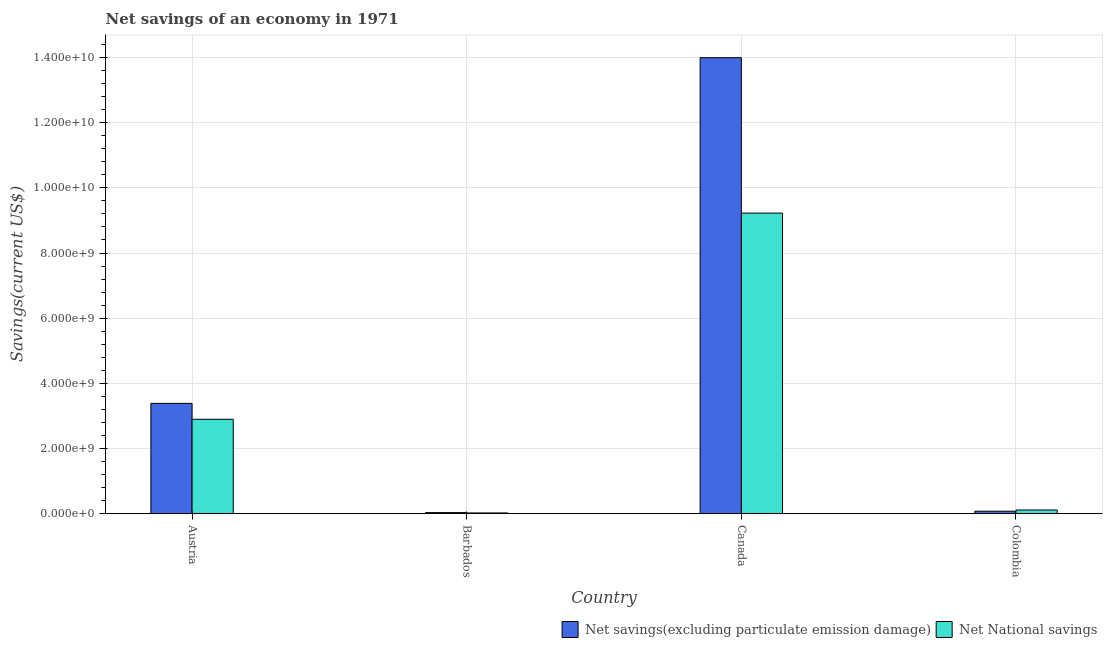How many different coloured bars are there?
Ensure brevity in your answer.  2. Are the number of bars per tick equal to the number of legend labels?
Offer a terse response. Yes. Are the number of bars on each tick of the X-axis equal?
Your response must be concise. Yes. How many bars are there on the 3rd tick from the right?
Offer a terse response. 2. What is the net national savings in Austria?
Provide a succinct answer. 2.90e+09. Across all countries, what is the maximum net national savings?
Provide a short and direct response. 9.23e+09. Across all countries, what is the minimum net savings(excluding particulate emission damage)?
Your answer should be very brief. 3.18e+07. In which country was the net national savings minimum?
Offer a terse response. Barbados. What is the total net national savings in the graph?
Your answer should be compact. 1.23e+1. What is the difference between the net national savings in Austria and that in Canada?
Provide a succinct answer. -6.33e+09. What is the difference between the net national savings in Canada and the net savings(excluding particulate emission damage) in Colombia?
Ensure brevity in your answer.  9.15e+09. What is the average net savings(excluding particulate emission damage) per country?
Ensure brevity in your answer.  4.37e+09. What is the difference between the net savings(excluding particulate emission damage) and net national savings in Austria?
Provide a succinct answer. 4.89e+08. In how many countries, is the net national savings greater than 2800000000 US$?
Your answer should be very brief. 2. What is the ratio of the net national savings in Austria to that in Canada?
Keep it short and to the point. 0.31. What is the difference between the highest and the second highest net savings(excluding particulate emission damage)?
Your answer should be very brief. 1.06e+1. What is the difference between the highest and the lowest net savings(excluding particulate emission damage)?
Provide a short and direct response. 1.40e+1. What does the 2nd bar from the left in Austria represents?
Give a very brief answer. Net National savings. What does the 2nd bar from the right in Colombia represents?
Ensure brevity in your answer.  Net savings(excluding particulate emission damage). Are all the bars in the graph horizontal?
Offer a terse response. No. How many countries are there in the graph?
Your answer should be very brief. 4. What is the difference between two consecutive major ticks on the Y-axis?
Offer a terse response. 2.00e+09. Does the graph contain any zero values?
Your response must be concise. No. Does the graph contain grids?
Provide a succinct answer. Yes. Where does the legend appear in the graph?
Offer a terse response. Bottom right. How many legend labels are there?
Offer a terse response. 2. What is the title of the graph?
Provide a short and direct response. Net savings of an economy in 1971. What is the label or title of the Y-axis?
Your response must be concise. Savings(current US$). What is the Savings(current US$) in Net savings(excluding particulate emission damage) in Austria?
Your response must be concise. 3.38e+09. What is the Savings(current US$) of Net National savings in Austria?
Ensure brevity in your answer.  2.90e+09. What is the Savings(current US$) of Net savings(excluding particulate emission damage) in Barbados?
Provide a short and direct response. 3.18e+07. What is the Savings(current US$) in Net National savings in Barbados?
Keep it short and to the point. 2.17e+07. What is the Savings(current US$) in Net savings(excluding particulate emission damage) in Canada?
Your response must be concise. 1.40e+1. What is the Savings(current US$) of Net National savings in Canada?
Provide a short and direct response. 9.23e+09. What is the Savings(current US$) in Net savings(excluding particulate emission damage) in Colombia?
Ensure brevity in your answer.  7.46e+07. What is the Savings(current US$) in Net National savings in Colombia?
Ensure brevity in your answer.  1.11e+08. Across all countries, what is the maximum Savings(current US$) in Net savings(excluding particulate emission damage)?
Give a very brief answer. 1.40e+1. Across all countries, what is the maximum Savings(current US$) of Net National savings?
Provide a succinct answer. 9.23e+09. Across all countries, what is the minimum Savings(current US$) of Net savings(excluding particulate emission damage)?
Give a very brief answer. 3.18e+07. Across all countries, what is the minimum Savings(current US$) in Net National savings?
Your answer should be very brief. 2.17e+07. What is the total Savings(current US$) of Net savings(excluding particulate emission damage) in the graph?
Provide a short and direct response. 1.75e+1. What is the total Savings(current US$) of Net National savings in the graph?
Provide a short and direct response. 1.23e+1. What is the difference between the Savings(current US$) in Net savings(excluding particulate emission damage) in Austria and that in Barbados?
Offer a terse response. 3.35e+09. What is the difference between the Savings(current US$) in Net National savings in Austria and that in Barbados?
Offer a terse response. 2.87e+09. What is the difference between the Savings(current US$) of Net savings(excluding particulate emission damage) in Austria and that in Canada?
Provide a succinct answer. -1.06e+1. What is the difference between the Savings(current US$) in Net National savings in Austria and that in Canada?
Provide a succinct answer. -6.33e+09. What is the difference between the Savings(current US$) in Net savings(excluding particulate emission damage) in Austria and that in Colombia?
Offer a very short reply. 3.31e+09. What is the difference between the Savings(current US$) of Net National savings in Austria and that in Colombia?
Offer a terse response. 2.78e+09. What is the difference between the Savings(current US$) of Net savings(excluding particulate emission damage) in Barbados and that in Canada?
Make the answer very short. -1.40e+1. What is the difference between the Savings(current US$) in Net National savings in Barbados and that in Canada?
Your answer should be compact. -9.20e+09. What is the difference between the Savings(current US$) of Net savings(excluding particulate emission damage) in Barbados and that in Colombia?
Give a very brief answer. -4.28e+07. What is the difference between the Savings(current US$) in Net National savings in Barbados and that in Colombia?
Ensure brevity in your answer.  -8.97e+07. What is the difference between the Savings(current US$) in Net savings(excluding particulate emission damage) in Canada and that in Colombia?
Make the answer very short. 1.39e+1. What is the difference between the Savings(current US$) of Net National savings in Canada and that in Colombia?
Offer a very short reply. 9.11e+09. What is the difference between the Savings(current US$) of Net savings(excluding particulate emission damage) in Austria and the Savings(current US$) of Net National savings in Barbados?
Give a very brief answer. 3.36e+09. What is the difference between the Savings(current US$) in Net savings(excluding particulate emission damage) in Austria and the Savings(current US$) in Net National savings in Canada?
Your response must be concise. -5.84e+09. What is the difference between the Savings(current US$) in Net savings(excluding particulate emission damage) in Austria and the Savings(current US$) in Net National savings in Colombia?
Give a very brief answer. 3.27e+09. What is the difference between the Savings(current US$) of Net savings(excluding particulate emission damage) in Barbados and the Savings(current US$) of Net National savings in Canada?
Provide a succinct answer. -9.19e+09. What is the difference between the Savings(current US$) in Net savings(excluding particulate emission damage) in Barbados and the Savings(current US$) in Net National savings in Colombia?
Your response must be concise. -7.96e+07. What is the difference between the Savings(current US$) of Net savings(excluding particulate emission damage) in Canada and the Savings(current US$) of Net National savings in Colombia?
Keep it short and to the point. 1.39e+1. What is the average Savings(current US$) in Net savings(excluding particulate emission damage) per country?
Your answer should be very brief. 4.37e+09. What is the average Savings(current US$) in Net National savings per country?
Offer a very short reply. 3.06e+09. What is the difference between the Savings(current US$) of Net savings(excluding particulate emission damage) and Savings(current US$) of Net National savings in Austria?
Keep it short and to the point. 4.89e+08. What is the difference between the Savings(current US$) in Net savings(excluding particulate emission damage) and Savings(current US$) in Net National savings in Barbados?
Make the answer very short. 1.01e+07. What is the difference between the Savings(current US$) in Net savings(excluding particulate emission damage) and Savings(current US$) in Net National savings in Canada?
Make the answer very short. 4.77e+09. What is the difference between the Savings(current US$) in Net savings(excluding particulate emission damage) and Savings(current US$) in Net National savings in Colombia?
Give a very brief answer. -3.68e+07. What is the ratio of the Savings(current US$) of Net savings(excluding particulate emission damage) in Austria to that in Barbados?
Provide a short and direct response. 106.5. What is the ratio of the Savings(current US$) in Net National savings in Austria to that in Barbados?
Make the answer very short. 133.41. What is the ratio of the Savings(current US$) of Net savings(excluding particulate emission damage) in Austria to that in Canada?
Keep it short and to the point. 0.24. What is the ratio of the Savings(current US$) of Net National savings in Austria to that in Canada?
Your answer should be compact. 0.31. What is the ratio of the Savings(current US$) of Net savings(excluding particulate emission damage) in Austria to that in Colombia?
Offer a very short reply. 45.37. What is the ratio of the Savings(current US$) of Net National savings in Austria to that in Colombia?
Offer a terse response. 25.99. What is the ratio of the Savings(current US$) of Net savings(excluding particulate emission damage) in Barbados to that in Canada?
Make the answer very short. 0. What is the ratio of the Savings(current US$) of Net National savings in Barbados to that in Canada?
Offer a very short reply. 0. What is the ratio of the Savings(current US$) of Net savings(excluding particulate emission damage) in Barbados to that in Colombia?
Your response must be concise. 0.43. What is the ratio of the Savings(current US$) in Net National savings in Barbados to that in Colombia?
Make the answer very short. 0.19. What is the ratio of the Savings(current US$) of Net savings(excluding particulate emission damage) in Canada to that in Colombia?
Offer a very short reply. 187.59. What is the ratio of the Savings(current US$) of Net National savings in Canada to that in Colombia?
Offer a terse response. 82.79. What is the difference between the highest and the second highest Savings(current US$) of Net savings(excluding particulate emission damage)?
Provide a short and direct response. 1.06e+1. What is the difference between the highest and the second highest Savings(current US$) of Net National savings?
Provide a succinct answer. 6.33e+09. What is the difference between the highest and the lowest Savings(current US$) of Net savings(excluding particulate emission damage)?
Provide a short and direct response. 1.40e+1. What is the difference between the highest and the lowest Savings(current US$) of Net National savings?
Provide a succinct answer. 9.20e+09. 